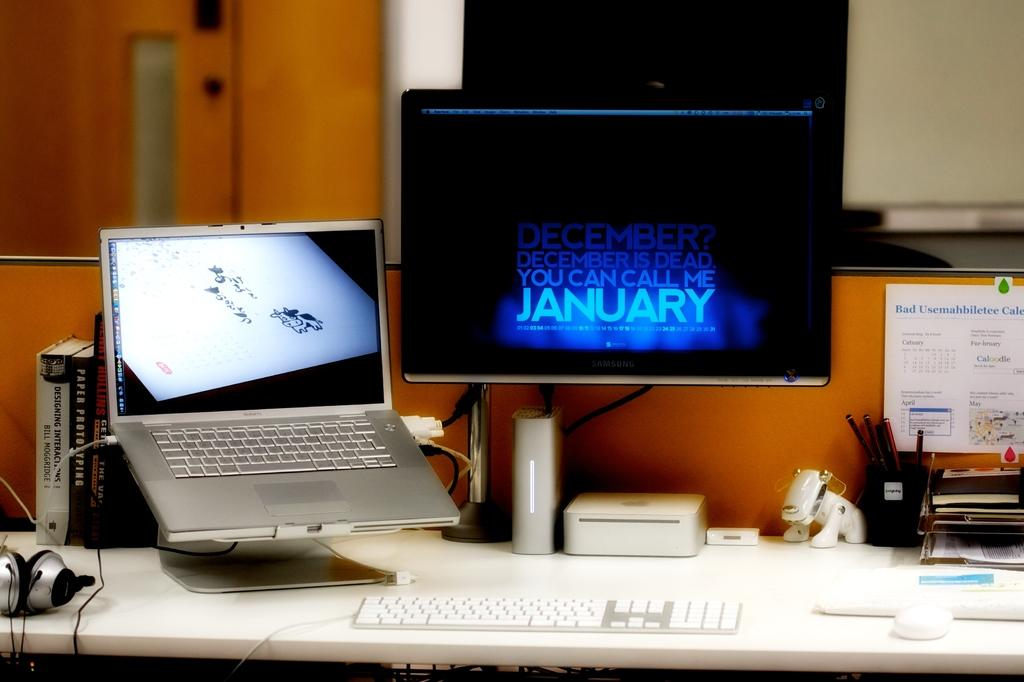What electronic device is visible in the image? There is a monitor and a laptop in the image. What items related to learning or reading can be seen in the image? There are books and boxes in the image. What decorative item is present in the image? There is a poster in the image. What input device is visible in the image? There is a keyboard in the image. What accessory is present for listening to audio? There are headphones in the image. What type of connection is present in the image? There are wires in the image. What is the condition of the top part of the image? The top of the image has a blurry view. How many babies are sitting on the plate in the image? There are no babies or plates present in the image. What type of skin condition can be seen on the person in the image? There is no person present in the image, so it is not possible to determine if they have any skin condition. 